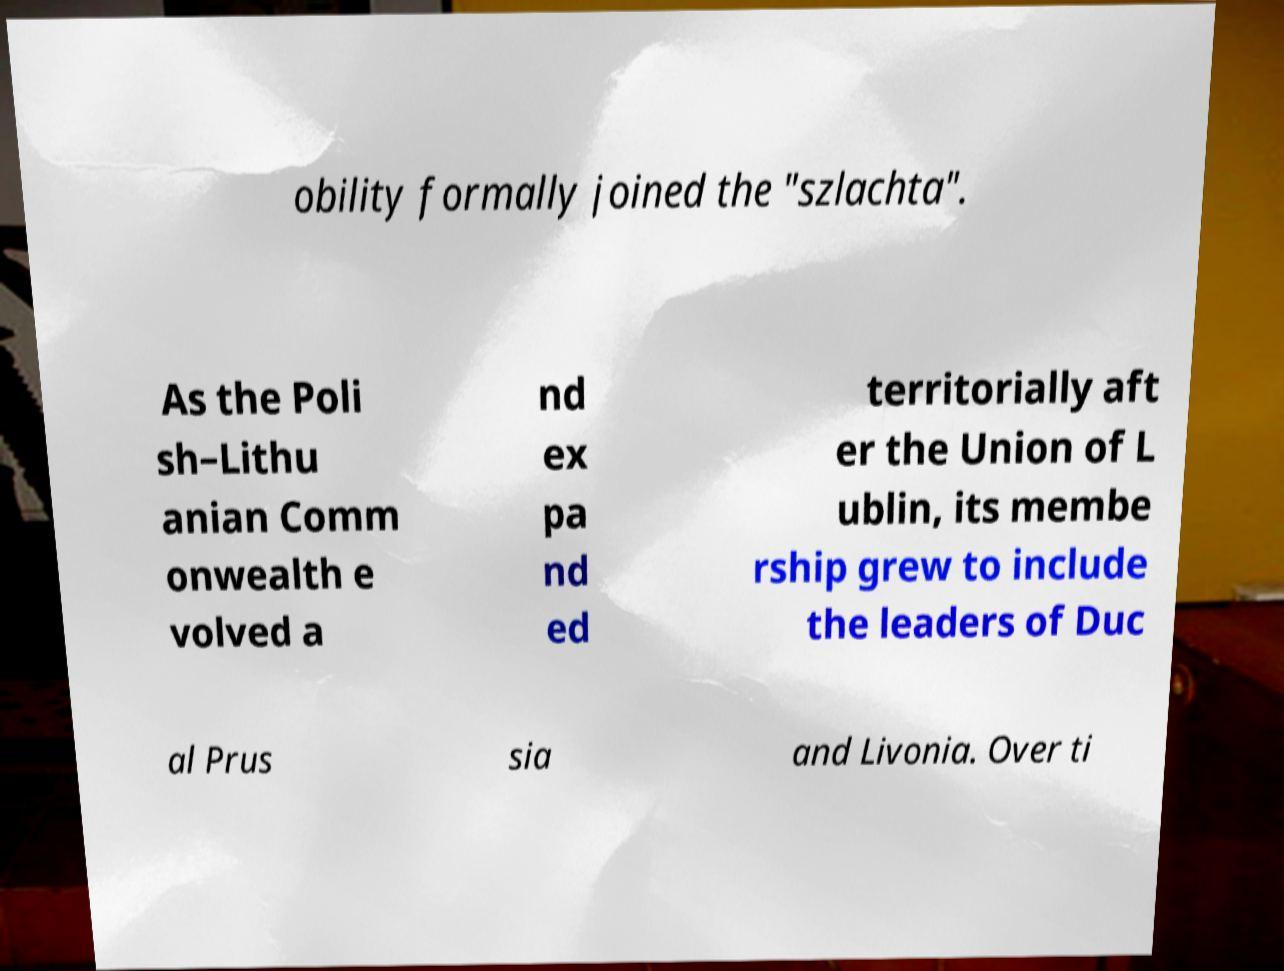I need the written content from this picture converted into text. Can you do that? obility formally joined the "szlachta". As the Poli sh–Lithu anian Comm onwealth e volved a nd ex pa nd ed territorially aft er the Union of L ublin, its membe rship grew to include the leaders of Duc al Prus sia and Livonia. Over ti 